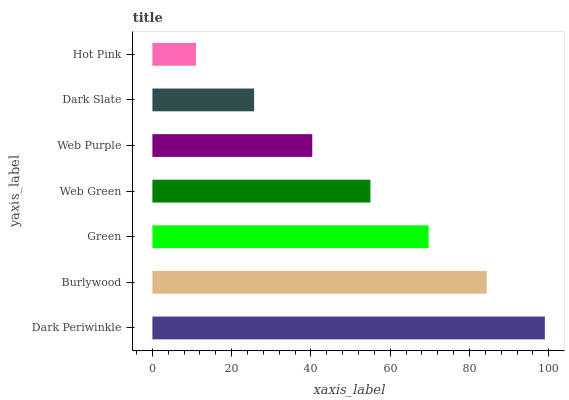Is Hot Pink the minimum?
Answer yes or no. Yes. Is Dark Periwinkle the maximum?
Answer yes or no. Yes. Is Burlywood the minimum?
Answer yes or no. No. Is Burlywood the maximum?
Answer yes or no. No. Is Dark Periwinkle greater than Burlywood?
Answer yes or no. Yes. Is Burlywood less than Dark Periwinkle?
Answer yes or no. Yes. Is Burlywood greater than Dark Periwinkle?
Answer yes or no. No. Is Dark Periwinkle less than Burlywood?
Answer yes or no. No. Is Web Green the high median?
Answer yes or no. Yes. Is Web Green the low median?
Answer yes or no. Yes. Is Burlywood the high median?
Answer yes or no. No. Is Green the low median?
Answer yes or no. No. 